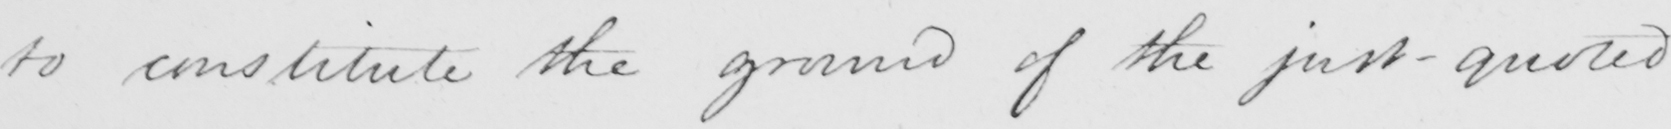Can you read and transcribe this handwriting? to constitute the ground of the just-quoted 